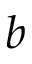Convert formula to latex. <formula><loc_0><loc_0><loc_500><loc_500>b</formula> 